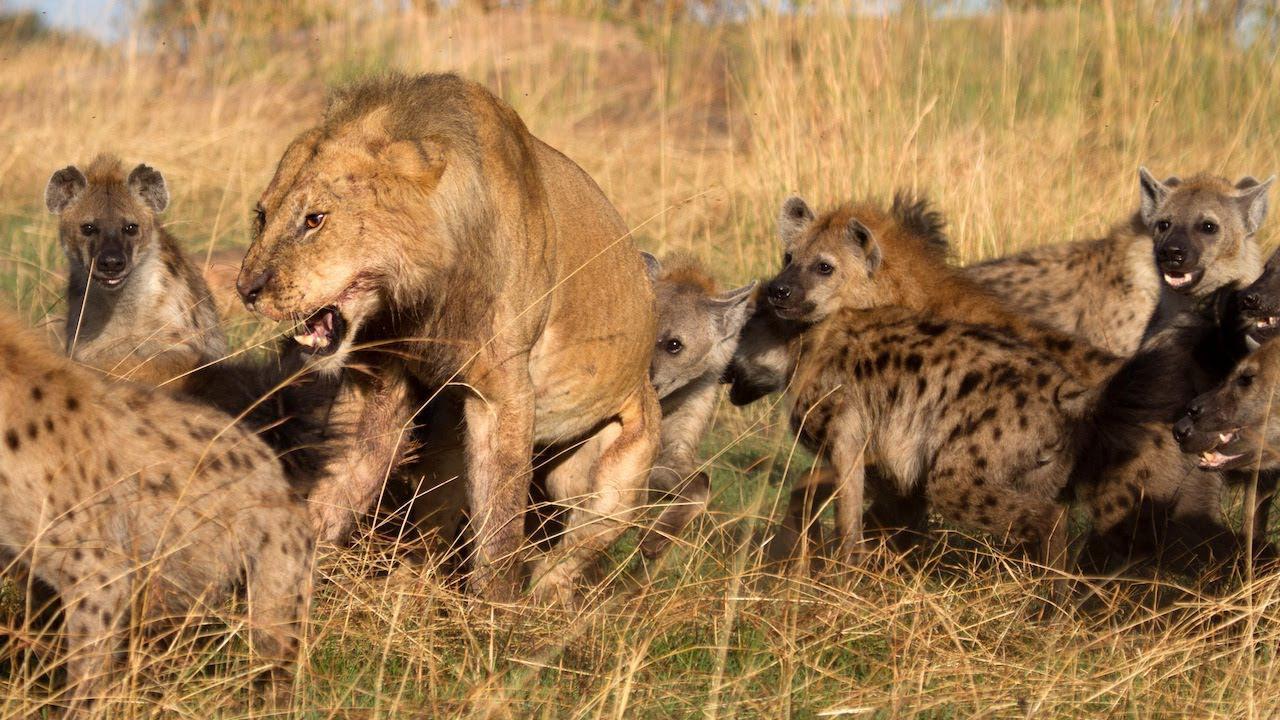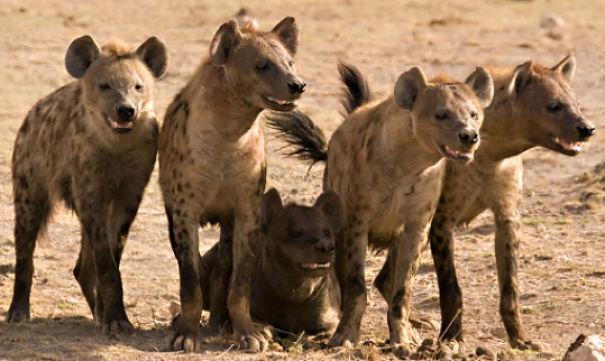The first image is the image on the left, the second image is the image on the right. Considering the images on both sides, is "An image shows an animal with fangs bared surrounded by hyenas." valid? Answer yes or no. Yes. 